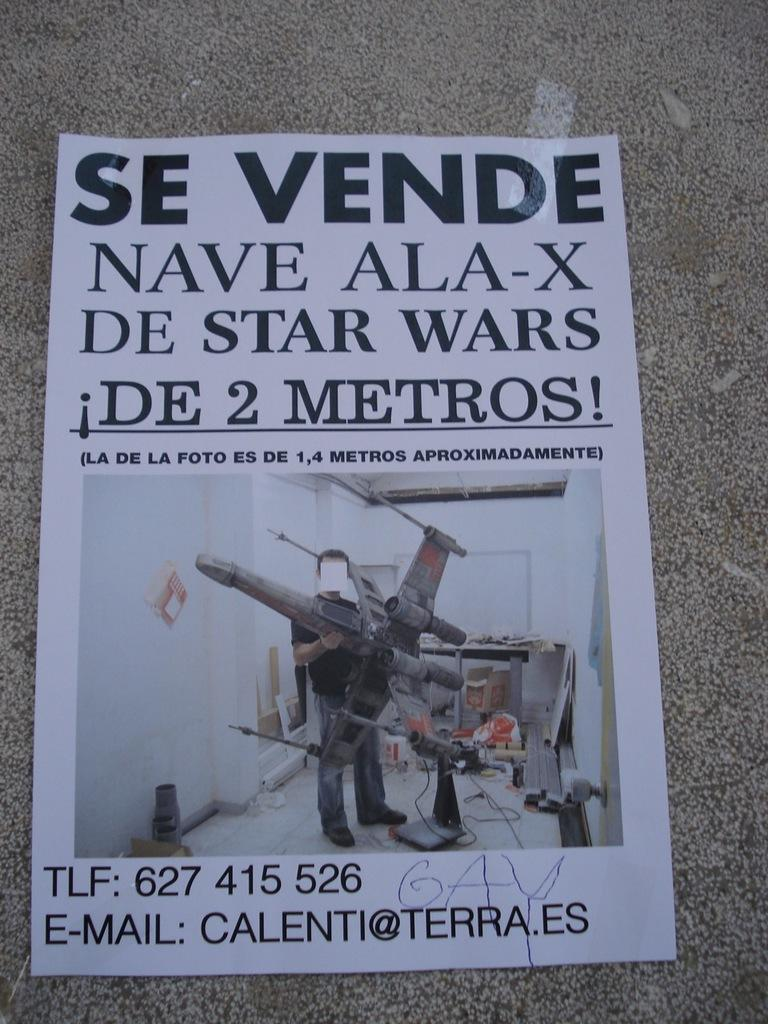<image>
Write a terse but informative summary of the picture. a poster with Nava Ala-x metros on it 